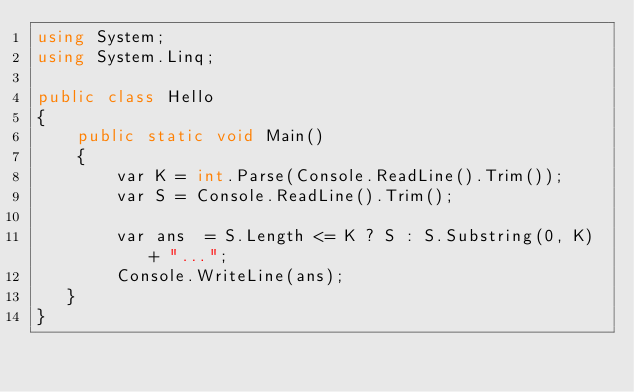<code> <loc_0><loc_0><loc_500><loc_500><_C#_>using System;
using System.Linq;

public class Hello
{
    public static void Main()
    {
        var K = int.Parse(Console.ReadLine().Trim());
        var S = Console.ReadLine().Trim();

        var ans  = S.Length <= K ? S : S.Substring(0, K) + "...";
        Console.WriteLine(ans);
   }
}</code> 